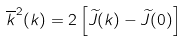Convert formula to latex. <formula><loc_0><loc_0><loc_500><loc_500>\overline { k } ^ { 2 } ( k ) = { 2 } \left [ \widetilde { J } ( k ) - \widetilde { J } ( 0 ) \right ]</formula> 